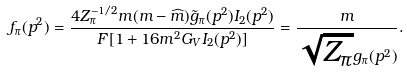Convert formula to latex. <formula><loc_0><loc_0><loc_500><loc_500>f _ { \pi } ( p ^ { 2 } ) = \frac { 4 Z ^ { - 1 / 2 } _ { \pi } m ( m - \widehat { m } ) \tilde { g } _ { \pi } ( p ^ { 2 } ) I _ { 2 } ( p ^ { 2 } ) } { F [ 1 + 1 6 m ^ { 2 } G _ { V } I _ { 2 } ( p ^ { 2 } ) ] } = \frac { m } { \sqrt { Z _ { \pi } } g _ { \pi } ( p ^ { 2 } ) } .</formula> 